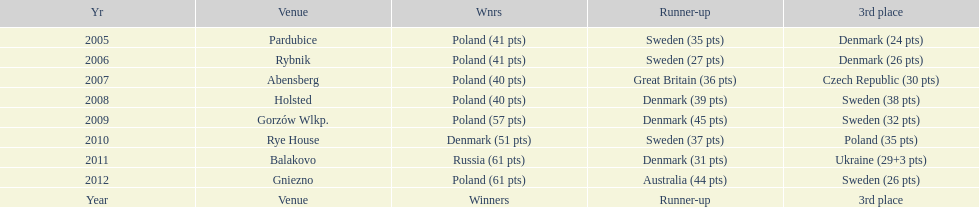After 2008 how many points total were scored by winners? 230. 